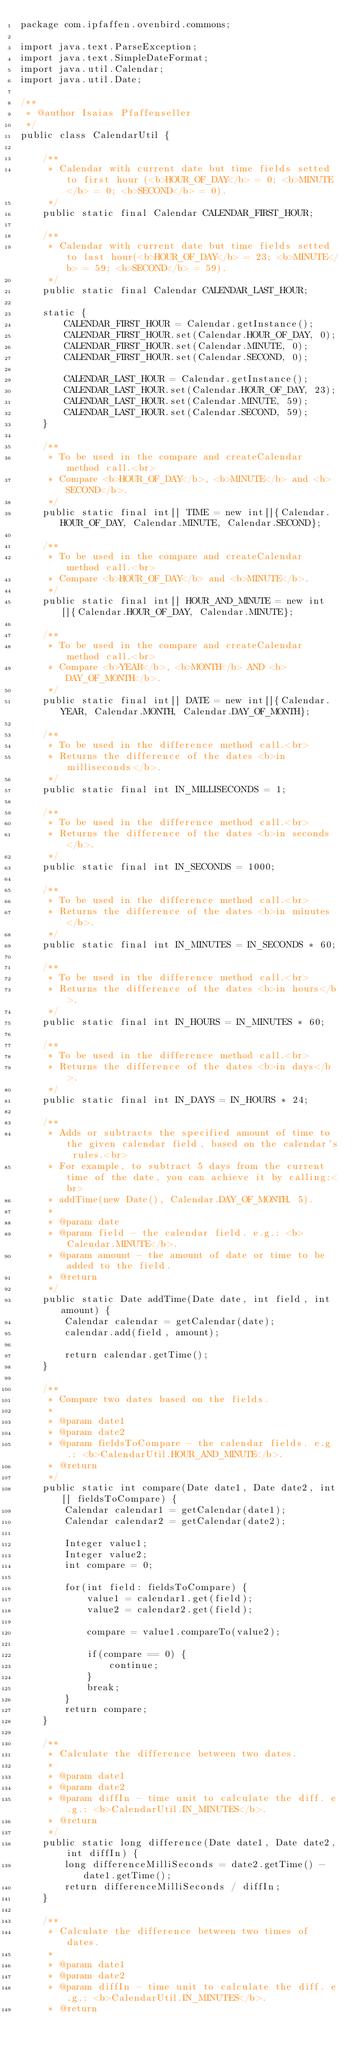Convert code to text. <code><loc_0><loc_0><loc_500><loc_500><_Java_>package com.ipfaffen.ovenbird.commons;

import java.text.ParseException;
import java.text.SimpleDateFormat;
import java.util.Calendar;
import java.util.Date;

/**
 * @author Isaias Pfaffenseller
 */
public class CalendarUtil {
	
	/**
	 * Calendar with current date but time fields setted to first hour (<b>HOUR_OF_DAY</b> = 0; <b>MINUTE</b> = 0; <b>SECOND</b> = 0).
	 */
	public static final Calendar CALENDAR_FIRST_HOUR;

	/**
	 * Calendar with current date but time fields setted to last hour(<b>HOUR_OF_DAY</b> = 23; <b>MINUTE</b> = 59; <b>SECOND</b> = 59).
	 */
	public static final Calendar CALENDAR_LAST_HOUR;

	static {
		CALENDAR_FIRST_HOUR = Calendar.getInstance();
		CALENDAR_FIRST_HOUR.set(Calendar.HOUR_OF_DAY, 0);
		CALENDAR_FIRST_HOUR.set(Calendar.MINUTE, 0);
		CALENDAR_FIRST_HOUR.set(Calendar.SECOND, 0);

		CALENDAR_LAST_HOUR = Calendar.getInstance();
		CALENDAR_LAST_HOUR.set(Calendar.HOUR_OF_DAY, 23);
		CALENDAR_LAST_HOUR.set(Calendar.MINUTE, 59);
		CALENDAR_LAST_HOUR.set(Calendar.SECOND, 59);
	}

	/**
	 * To be used in the compare and createCalendar method call.<br>
	 * Compare <b>HOUR_OF_DAY</b>, <b>MINUTE</b> and <b>SECOND</b>.
	 */
	public static final int[] TIME = new int[]{Calendar.HOUR_OF_DAY, Calendar.MINUTE, Calendar.SECOND};

	/**
	 * To be used in the compare and createCalendar method call.<br>
	 * Compare <b>HOUR_OF_DAY</b> and <b>MINUTE</b>.
	 */
	public static final int[] HOUR_AND_MINUTE = new int[]{Calendar.HOUR_OF_DAY, Calendar.MINUTE};

	/**
	 * To be used in the compare and createCalendar method call.<br>
	 * Compare <b>YEAR</b>, <b>MONTH</b> AND <b>DAY_OF_MONTH</b>.
	 */
	public static final int[] DATE = new int[]{Calendar.YEAR, Calendar.MONTH, Calendar.DAY_OF_MONTH};

	/**
	 * To be used in the difference method call.<br>
	 * Returns the difference of the dates <b>in milliseconds</b>.
	 */
	public static final int IN_MILLISECONDS = 1;

	/**
	 * To be used in the difference method call.<br>
	 * Returns the difference of the dates <b>in seconds</b>.
	 */
	public static final int IN_SECONDS = 1000;

	/**
	 * To be used in the difference method call.<br>
	 * Returns the difference of the dates <b>in minutes</b>.
	 */
	public static final int IN_MINUTES = IN_SECONDS * 60;

	/**
	 * To be used in the difference method call.<br>
	 * Returns the difference of the dates <b>in hours</b>.
	 */
	public static final int IN_HOURS = IN_MINUTES * 60;

	/**
	 * To be used in the difference method call.<br>
	 * Returns the difference of the dates <b>in days</b>.
	 */
	public static final int IN_DAYS = IN_HOURS * 24;

	/**
	 * Adds or subtracts the specified amount of time to the given calendar field, based on the calendar's rules.<br>
	 * For example, to subtract 5 days from the current time of the date, you can achieve it by calling:<br>
	 * addTime(new Date(), Calendar.DAY_OF_MONTH, 5).
	 * 
	 * @param date
	 * @param field - the calendar field. e.g.: <b>Calendar.MINUTE</b>.
	 * @param amount - the amount of date or time to be added to the field.
	 * @return
	 */
	public static Date addTime(Date date, int field, int amount) {
		Calendar calendar = getCalendar(date);
		calendar.add(field, amount);

		return calendar.getTime();
	}

	/**
	 * Compare two dates based on the fields.
	 * 
	 * @param date1
	 * @param date2
	 * @param fieldsToCompare - the calendar fields. e.g.: <b>CalendarUtil.HOUR_AND_MINUTE</b>.
	 * @return
	 */
	public static int compare(Date date1, Date date2, int[] fieldsToCompare) {
		Calendar calendar1 = getCalendar(date1);
		Calendar calendar2 = getCalendar(date2);

		Integer value1;
		Integer value2;
		int compare = 0;

		for(int field: fieldsToCompare) {
			value1 = calendar1.get(field);
			value2 = calendar2.get(field);

			compare = value1.compareTo(value2);

			if(compare == 0) {
				continue;
			}
			break;
		}
		return compare;
	}

	/**
	 * Calculate the difference between two dates.
	 * 
	 * @param date1
	 * @param date2
	 * @param diffIn - time unit to calculate the diff. e.g.: <b>CalendarUtil.IN_MINUTES</b>.
	 * @return
	 */
	public static long difference(Date date1, Date date2, int diffIn) {
		long differenceMilliSeconds = date2.getTime() - date1.getTime();
		return differenceMilliSeconds / diffIn;
	}

	/**
	 * Calculate the difference between two times of dates.
	 * 
	 * @param date1
	 * @param date2
	 * @param diffIn - time unit to calculate the diff. e.g.: <b>CalendarUtil.IN_MINUTES</b>.
	 * @return</code> 